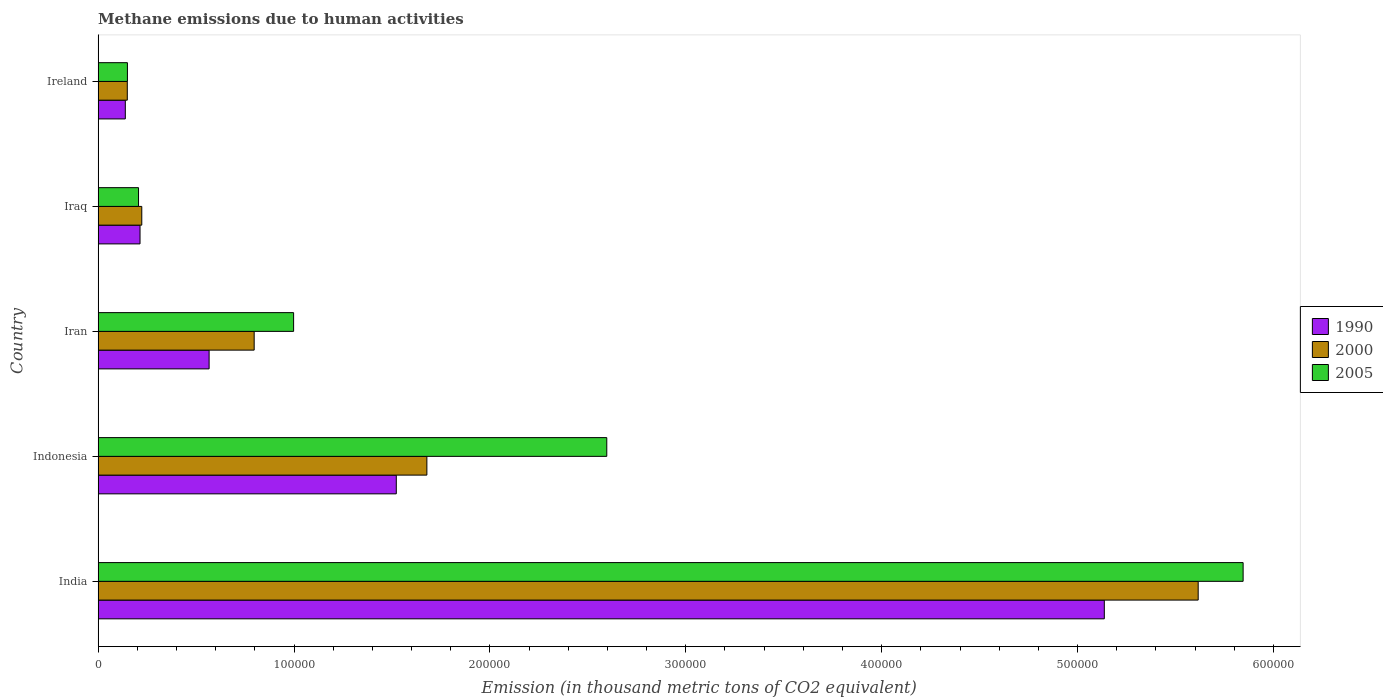How many different coloured bars are there?
Offer a very short reply. 3. How many bars are there on the 2nd tick from the top?
Provide a short and direct response. 3. What is the label of the 3rd group of bars from the top?
Your answer should be compact. Iran. In how many cases, is the number of bars for a given country not equal to the number of legend labels?
Your answer should be very brief. 0. What is the amount of methane emitted in 2005 in Ireland?
Ensure brevity in your answer.  1.50e+04. Across all countries, what is the maximum amount of methane emitted in 1990?
Your answer should be compact. 5.14e+05. Across all countries, what is the minimum amount of methane emitted in 2005?
Give a very brief answer. 1.50e+04. In which country was the amount of methane emitted in 1990 minimum?
Offer a very short reply. Ireland. What is the total amount of methane emitted in 2005 in the graph?
Offer a terse response. 9.80e+05. What is the difference between the amount of methane emitted in 2005 in Indonesia and that in Iraq?
Give a very brief answer. 2.39e+05. What is the difference between the amount of methane emitted in 2000 in Ireland and the amount of methane emitted in 1990 in Iran?
Make the answer very short. -4.18e+04. What is the average amount of methane emitted in 2000 per country?
Your response must be concise. 1.69e+05. What is the difference between the amount of methane emitted in 1990 and amount of methane emitted in 2005 in Ireland?
Ensure brevity in your answer.  -1076.2. What is the ratio of the amount of methane emitted in 2000 in India to that in Indonesia?
Provide a succinct answer. 3.35. Is the amount of methane emitted in 1990 in Indonesia less than that in Ireland?
Keep it short and to the point. No. What is the difference between the highest and the second highest amount of methane emitted in 2000?
Your answer should be very brief. 3.94e+05. What is the difference between the highest and the lowest amount of methane emitted in 2005?
Your answer should be compact. 5.70e+05. How many bars are there?
Give a very brief answer. 15. What is the difference between two consecutive major ticks on the X-axis?
Your answer should be compact. 1.00e+05. Are the values on the major ticks of X-axis written in scientific E-notation?
Give a very brief answer. No. Does the graph contain grids?
Your answer should be compact. No. Where does the legend appear in the graph?
Offer a terse response. Center right. How are the legend labels stacked?
Provide a short and direct response. Vertical. What is the title of the graph?
Give a very brief answer. Methane emissions due to human activities. Does "1987" appear as one of the legend labels in the graph?
Make the answer very short. No. What is the label or title of the X-axis?
Give a very brief answer. Emission (in thousand metric tons of CO2 equivalent). What is the label or title of the Y-axis?
Offer a terse response. Country. What is the Emission (in thousand metric tons of CO2 equivalent) of 1990 in India?
Make the answer very short. 5.14e+05. What is the Emission (in thousand metric tons of CO2 equivalent) in 2000 in India?
Make the answer very short. 5.62e+05. What is the Emission (in thousand metric tons of CO2 equivalent) in 2005 in India?
Your answer should be very brief. 5.84e+05. What is the Emission (in thousand metric tons of CO2 equivalent) of 1990 in Indonesia?
Your response must be concise. 1.52e+05. What is the Emission (in thousand metric tons of CO2 equivalent) in 2000 in Indonesia?
Your response must be concise. 1.68e+05. What is the Emission (in thousand metric tons of CO2 equivalent) in 2005 in Indonesia?
Offer a very short reply. 2.60e+05. What is the Emission (in thousand metric tons of CO2 equivalent) in 1990 in Iran?
Your response must be concise. 5.67e+04. What is the Emission (in thousand metric tons of CO2 equivalent) in 2000 in Iran?
Offer a very short reply. 7.97e+04. What is the Emission (in thousand metric tons of CO2 equivalent) of 2005 in Iran?
Provide a succinct answer. 9.98e+04. What is the Emission (in thousand metric tons of CO2 equivalent) of 1990 in Iraq?
Offer a terse response. 2.14e+04. What is the Emission (in thousand metric tons of CO2 equivalent) of 2000 in Iraq?
Your answer should be very brief. 2.23e+04. What is the Emission (in thousand metric tons of CO2 equivalent) of 2005 in Iraq?
Make the answer very short. 2.06e+04. What is the Emission (in thousand metric tons of CO2 equivalent) in 1990 in Ireland?
Provide a succinct answer. 1.39e+04. What is the Emission (in thousand metric tons of CO2 equivalent) of 2000 in Ireland?
Provide a short and direct response. 1.49e+04. What is the Emission (in thousand metric tons of CO2 equivalent) of 2005 in Ireland?
Provide a succinct answer. 1.50e+04. Across all countries, what is the maximum Emission (in thousand metric tons of CO2 equivalent) of 1990?
Keep it short and to the point. 5.14e+05. Across all countries, what is the maximum Emission (in thousand metric tons of CO2 equivalent) in 2000?
Ensure brevity in your answer.  5.62e+05. Across all countries, what is the maximum Emission (in thousand metric tons of CO2 equivalent) in 2005?
Offer a very short reply. 5.84e+05. Across all countries, what is the minimum Emission (in thousand metric tons of CO2 equivalent) in 1990?
Keep it short and to the point. 1.39e+04. Across all countries, what is the minimum Emission (in thousand metric tons of CO2 equivalent) in 2000?
Ensure brevity in your answer.  1.49e+04. Across all countries, what is the minimum Emission (in thousand metric tons of CO2 equivalent) in 2005?
Your answer should be very brief. 1.50e+04. What is the total Emission (in thousand metric tons of CO2 equivalent) in 1990 in the graph?
Your answer should be compact. 7.58e+05. What is the total Emission (in thousand metric tons of CO2 equivalent) in 2000 in the graph?
Provide a succinct answer. 8.46e+05. What is the total Emission (in thousand metric tons of CO2 equivalent) in 2005 in the graph?
Ensure brevity in your answer.  9.80e+05. What is the difference between the Emission (in thousand metric tons of CO2 equivalent) in 1990 in India and that in Indonesia?
Provide a succinct answer. 3.61e+05. What is the difference between the Emission (in thousand metric tons of CO2 equivalent) in 2000 in India and that in Indonesia?
Provide a short and direct response. 3.94e+05. What is the difference between the Emission (in thousand metric tons of CO2 equivalent) in 2005 in India and that in Indonesia?
Your response must be concise. 3.25e+05. What is the difference between the Emission (in thousand metric tons of CO2 equivalent) in 1990 in India and that in Iran?
Provide a short and direct response. 4.57e+05. What is the difference between the Emission (in thousand metric tons of CO2 equivalent) of 2000 in India and that in Iran?
Your answer should be very brief. 4.82e+05. What is the difference between the Emission (in thousand metric tons of CO2 equivalent) of 2005 in India and that in Iran?
Your response must be concise. 4.85e+05. What is the difference between the Emission (in thousand metric tons of CO2 equivalent) in 1990 in India and that in Iraq?
Offer a terse response. 4.92e+05. What is the difference between the Emission (in thousand metric tons of CO2 equivalent) in 2000 in India and that in Iraq?
Make the answer very short. 5.39e+05. What is the difference between the Emission (in thousand metric tons of CO2 equivalent) in 2005 in India and that in Iraq?
Provide a short and direct response. 5.64e+05. What is the difference between the Emission (in thousand metric tons of CO2 equivalent) in 1990 in India and that in Ireland?
Ensure brevity in your answer.  5.00e+05. What is the difference between the Emission (in thousand metric tons of CO2 equivalent) in 2000 in India and that in Ireland?
Give a very brief answer. 5.47e+05. What is the difference between the Emission (in thousand metric tons of CO2 equivalent) in 2005 in India and that in Ireland?
Keep it short and to the point. 5.70e+05. What is the difference between the Emission (in thousand metric tons of CO2 equivalent) in 1990 in Indonesia and that in Iran?
Offer a terse response. 9.55e+04. What is the difference between the Emission (in thousand metric tons of CO2 equivalent) in 2000 in Indonesia and that in Iran?
Keep it short and to the point. 8.82e+04. What is the difference between the Emission (in thousand metric tons of CO2 equivalent) of 2005 in Indonesia and that in Iran?
Offer a terse response. 1.60e+05. What is the difference between the Emission (in thousand metric tons of CO2 equivalent) in 1990 in Indonesia and that in Iraq?
Offer a very short reply. 1.31e+05. What is the difference between the Emission (in thousand metric tons of CO2 equivalent) of 2000 in Indonesia and that in Iraq?
Offer a very short reply. 1.46e+05. What is the difference between the Emission (in thousand metric tons of CO2 equivalent) in 2005 in Indonesia and that in Iraq?
Keep it short and to the point. 2.39e+05. What is the difference between the Emission (in thousand metric tons of CO2 equivalent) of 1990 in Indonesia and that in Ireland?
Your response must be concise. 1.38e+05. What is the difference between the Emission (in thousand metric tons of CO2 equivalent) in 2000 in Indonesia and that in Ireland?
Your response must be concise. 1.53e+05. What is the difference between the Emission (in thousand metric tons of CO2 equivalent) of 2005 in Indonesia and that in Ireland?
Provide a short and direct response. 2.45e+05. What is the difference between the Emission (in thousand metric tons of CO2 equivalent) in 1990 in Iran and that in Iraq?
Make the answer very short. 3.53e+04. What is the difference between the Emission (in thousand metric tons of CO2 equivalent) of 2000 in Iran and that in Iraq?
Your answer should be very brief. 5.74e+04. What is the difference between the Emission (in thousand metric tons of CO2 equivalent) of 2005 in Iran and that in Iraq?
Provide a succinct answer. 7.92e+04. What is the difference between the Emission (in thousand metric tons of CO2 equivalent) in 1990 in Iran and that in Ireland?
Make the answer very short. 4.28e+04. What is the difference between the Emission (in thousand metric tons of CO2 equivalent) in 2000 in Iran and that in Ireland?
Give a very brief answer. 6.48e+04. What is the difference between the Emission (in thousand metric tons of CO2 equivalent) in 2005 in Iran and that in Ireland?
Ensure brevity in your answer.  8.48e+04. What is the difference between the Emission (in thousand metric tons of CO2 equivalent) in 1990 in Iraq and that in Ireland?
Your answer should be compact. 7511.4. What is the difference between the Emission (in thousand metric tons of CO2 equivalent) in 2000 in Iraq and that in Ireland?
Offer a terse response. 7392. What is the difference between the Emission (in thousand metric tons of CO2 equivalent) in 2005 in Iraq and that in Ireland?
Keep it short and to the point. 5668. What is the difference between the Emission (in thousand metric tons of CO2 equivalent) in 1990 in India and the Emission (in thousand metric tons of CO2 equivalent) in 2000 in Indonesia?
Your response must be concise. 3.46e+05. What is the difference between the Emission (in thousand metric tons of CO2 equivalent) of 1990 in India and the Emission (in thousand metric tons of CO2 equivalent) of 2005 in Indonesia?
Your answer should be compact. 2.54e+05. What is the difference between the Emission (in thousand metric tons of CO2 equivalent) in 2000 in India and the Emission (in thousand metric tons of CO2 equivalent) in 2005 in Indonesia?
Your answer should be very brief. 3.02e+05. What is the difference between the Emission (in thousand metric tons of CO2 equivalent) of 1990 in India and the Emission (in thousand metric tons of CO2 equivalent) of 2000 in Iran?
Provide a short and direct response. 4.34e+05. What is the difference between the Emission (in thousand metric tons of CO2 equivalent) in 1990 in India and the Emission (in thousand metric tons of CO2 equivalent) in 2005 in Iran?
Provide a short and direct response. 4.14e+05. What is the difference between the Emission (in thousand metric tons of CO2 equivalent) in 2000 in India and the Emission (in thousand metric tons of CO2 equivalent) in 2005 in Iran?
Your answer should be very brief. 4.62e+05. What is the difference between the Emission (in thousand metric tons of CO2 equivalent) of 1990 in India and the Emission (in thousand metric tons of CO2 equivalent) of 2000 in Iraq?
Provide a succinct answer. 4.91e+05. What is the difference between the Emission (in thousand metric tons of CO2 equivalent) of 1990 in India and the Emission (in thousand metric tons of CO2 equivalent) of 2005 in Iraq?
Make the answer very short. 4.93e+05. What is the difference between the Emission (in thousand metric tons of CO2 equivalent) in 2000 in India and the Emission (in thousand metric tons of CO2 equivalent) in 2005 in Iraq?
Offer a very short reply. 5.41e+05. What is the difference between the Emission (in thousand metric tons of CO2 equivalent) in 1990 in India and the Emission (in thousand metric tons of CO2 equivalent) in 2000 in Ireland?
Offer a terse response. 4.99e+05. What is the difference between the Emission (in thousand metric tons of CO2 equivalent) of 1990 in India and the Emission (in thousand metric tons of CO2 equivalent) of 2005 in Ireland?
Your answer should be very brief. 4.99e+05. What is the difference between the Emission (in thousand metric tons of CO2 equivalent) of 2000 in India and the Emission (in thousand metric tons of CO2 equivalent) of 2005 in Ireland?
Provide a short and direct response. 5.47e+05. What is the difference between the Emission (in thousand metric tons of CO2 equivalent) of 1990 in Indonesia and the Emission (in thousand metric tons of CO2 equivalent) of 2000 in Iran?
Keep it short and to the point. 7.25e+04. What is the difference between the Emission (in thousand metric tons of CO2 equivalent) of 1990 in Indonesia and the Emission (in thousand metric tons of CO2 equivalent) of 2005 in Iran?
Keep it short and to the point. 5.24e+04. What is the difference between the Emission (in thousand metric tons of CO2 equivalent) of 2000 in Indonesia and the Emission (in thousand metric tons of CO2 equivalent) of 2005 in Iran?
Make the answer very short. 6.80e+04. What is the difference between the Emission (in thousand metric tons of CO2 equivalent) of 1990 in Indonesia and the Emission (in thousand metric tons of CO2 equivalent) of 2000 in Iraq?
Provide a succinct answer. 1.30e+05. What is the difference between the Emission (in thousand metric tons of CO2 equivalent) in 1990 in Indonesia and the Emission (in thousand metric tons of CO2 equivalent) in 2005 in Iraq?
Keep it short and to the point. 1.32e+05. What is the difference between the Emission (in thousand metric tons of CO2 equivalent) of 2000 in Indonesia and the Emission (in thousand metric tons of CO2 equivalent) of 2005 in Iraq?
Your response must be concise. 1.47e+05. What is the difference between the Emission (in thousand metric tons of CO2 equivalent) in 1990 in Indonesia and the Emission (in thousand metric tons of CO2 equivalent) in 2000 in Ireland?
Your answer should be very brief. 1.37e+05. What is the difference between the Emission (in thousand metric tons of CO2 equivalent) in 1990 in Indonesia and the Emission (in thousand metric tons of CO2 equivalent) in 2005 in Ireland?
Ensure brevity in your answer.  1.37e+05. What is the difference between the Emission (in thousand metric tons of CO2 equivalent) in 2000 in Indonesia and the Emission (in thousand metric tons of CO2 equivalent) in 2005 in Ireland?
Give a very brief answer. 1.53e+05. What is the difference between the Emission (in thousand metric tons of CO2 equivalent) of 1990 in Iran and the Emission (in thousand metric tons of CO2 equivalent) of 2000 in Iraq?
Provide a short and direct response. 3.44e+04. What is the difference between the Emission (in thousand metric tons of CO2 equivalent) in 1990 in Iran and the Emission (in thousand metric tons of CO2 equivalent) in 2005 in Iraq?
Make the answer very short. 3.60e+04. What is the difference between the Emission (in thousand metric tons of CO2 equivalent) in 2000 in Iran and the Emission (in thousand metric tons of CO2 equivalent) in 2005 in Iraq?
Make the answer very short. 5.90e+04. What is the difference between the Emission (in thousand metric tons of CO2 equivalent) of 1990 in Iran and the Emission (in thousand metric tons of CO2 equivalent) of 2000 in Ireland?
Ensure brevity in your answer.  4.18e+04. What is the difference between the Emission (in thousand metric tons of CO2 equivalent) of 1990 in Iran and the Emission (in thousand metric tons of CO2 equivalent) of 2005 in Ireland?
Keep it short and to the point. 4.17e+04. What is the difference between the Emission (in thousand metric tons of CO2 equivalent) in 2000 in Iran and the Emission (in thousand metric tons of CO2 equivalent) in 2005 in Ireland?
Ensure brevity in your answer.  6.47e+04. What is the difference between the Emission (in thousand metric tons of CO2 equivalent) of 1990 in Iraq and the Emission (in thousand metric tons of CO2 equivalent) of 2000 in Ireland?
Ensure brevity in your answer.  6498.3. What is the difference between the Emission (in thousand metric tons of CO2 equivalent) in 1990 in Iraq and the Emission (in thousand metric tons of CO2 equivalent) in 2005 in Ireland?
Offer a terse response. 6435.2. What is the difference between the Emission (in thousand metric tons of CO2 equivalent) in 2000 in Iraq and the Emission (in thousand metric tons of CO2 equivalent) in 2005 in Ireland?
Provide a short and direct response. 7328.9. What is the average Emission (in thousand metric tons of CO2 equivalent) of 1990 per country?
Make the answer very short. 1.52e+05. What is the average Emission (in thousand metric tons of CO2 equivalent) in 2000 per country?
Your answer should be compact. 1.69e+05. What is the average Emission (in thousand metric tons of CO2 equivalent) of 2005 per country?
Keep it short and to the point. 1.96e+05. What is the difference between the Emission (in thousand metric tons of CO2 equivalent) of 1990 and Emission (in thousand metric tons of CO2 equivalent) of 2000 in India?
Ensure brevity in your answer.  -4.79e+04. What is the difference between the Emission (in thousand metric tons of CO2 equivalent) in 1990 and Emission (in thousand metric tons of CO2 equivalent) in 2005 in India?
Ensure brevity in your answer.  -7.09e+04. What is the difference between the Emission (in thousand metric tons of CO2 equivalent) of 2000 and Emission (in thousand metric tons of CO2 equivalent) of 2005 in India?
Offer a very short reply. -2.29e+04. What is the difference between the Emission (in thousand metric tons of CO2 equivalent) in 1990 and Emission (in thousand metric tons of CO2 equivalent) in 2000 in Indonesia?
Make the answer very short. -1.56e+04. What is the difference between the Emission (in thousand metric tons of CO2 equivalent) of 1990 and Emission (in thousand metric tons of CO2 equivalent) of 2005 in Indonesia?
Your answer should be very brief. -1.07e+05. What is the difference between the Emission (in thousand metric tons of CO2 equivalent) in 2000 and Emission (in thousand metric tons of CO2 equivalent) in 2005 in Indonesia?
Ensure brevity in your answer.  -9.18e+04. What is the difference between the Emission (in thousand metric tons of CO2 equivalent) of 1990 and Emission (in thousand metric tons of CO2 equivalent) of 2000 in Iran?
Provide a short and direct response. -2.30e+04. What is the difference between the Emission (in thousand metric tons of CO2 equivalent) in 1990 and Emission (in thousand metric tons of CO2 equivalent) in 2005 in Iran?
Your response must be concise. -4.31e+04. What is the difference between the Emission (in thousand metric tons of CO2 equivalent) of 2000 and Emission (in thousand metric tons of CO2 equivalent) of 2005 in Iran?
Offer a very short reply. -2.01e+04. What is the difference between the Emission (in thousand metric tons of CO2 equivalent) in 1990 and Emission (in thousand metric tons of CO2 equivalent) in 2000 in Iraq?
Make the answer very short. -893.7. What is the difference between the Emission (in thousand metric tons of CO2 equivalent) in 1990 and Emission (in thousand metric tons of CO2 equivalent) in 2005 in Iraq?
Provide a short and direct response. 767.2. What is the difference between the Emission (in thousand metric tons of CO2 equivalent) in 2000 and Emission (in thousand metric tons of CO2 equivalent) in 2005 in Iraq?
Ensure brevity in your answer.  1660.9. What is the difference between the Emission (in thousand metric tons of CO2 equivalent) of 1990 and Emission (in thousand metric tons of CO2 equivalent) of 2000 in Ireland?
Ensure brevity in your answer.  -1013.1. What is the difference between the Emission (in thousand metric tons of CO2 equivalent) in 1990 and Emission (in thousand metric tons of CO2 equivalent) in 2005 in Ireland?
Give a very brief answer. -1076.2. What is the difference between the Emission (in thousand metric tons of CO2 equivalent) in 2000 and Emission (in thousand metric tons of CO2 equivalent) in 2005 in Ireland?
Offer a very short reply. -63.1. What is the ratio of the Emission (in thousand metric tons of CO2 equivalent) of 1990 in India to that in Indonesia?
Your answer should be very brief. 3.37. What is the ratio of the Emission (in thousand metric tons of CO2 equivalent) of 2000 in India to that in Indonesia?
Make the answer very short. 3.35. What is the ratio of the Emission (in thousand metric tons of CO2 equivalent) of 2005 in India to that in Indonesia?
Give a very brief answer. 2.25. What is the ratio of the Emission (in thousand metric tons of CO2 equivalent) of 1990 in India to that in Iran?
Give a very brief answer. 9.06. What is the ratio of the Emission (in thousand metric tons of CO2 equivalent) of 2000 in India to that in Iran?
Offer a very short reply. 7.05. What is the ratio of the Emission (in thousand metric tons of CO2 equivalent) in 2005 in India to that in Iran?
Your answer should be very brief. 5.86. What is the ratio of the Emission (in thousand metric tons of CO2 equivalent) of 1990 in India to that in Iraq?
Your response must be concise. 24.01. What is the ratio of the Emission (in thousand metric tons of CO2 equivalent) in 2000 in India to that in Iraq?
Make the answer very short. 25.19. What is the ratio of the Emission (in thousand metric tons of CO2 equivalent) in 2005 in India to that in Iraq?
Offer a very short reply. 28.33. What is the ratio of the Emission (in thousand metric tons of CO2 equivalent) of 1990 in India to that in Ireland?
Ensure brevity in your answer.  37. What is the ratio of the Emission (in thousand metric tons of CO2 equivalent) of 2000 in India to that in Ireland?
Provide a succinct answer. 37.7. What is the ratio of the Emission (in thousand metric tons of CO2 equivalent) in 2005 in India to that in Ireland?
Keep it short and to the point. 39.07. What is the ratio of the Emission (in thousand metric tons of CO2 equivalent) in 1990 in Indonesia to that in Iran?
Your answer should be compact. 2.69. What is the ratio of the Emission (in thousand metric tons of CO2 equivalent) in 2000 in Indonesia to that in Iran?
Ensure brevity in your answer.  2.11. What is the ratio of the Emission (in thousand metric tons of CO2 equivalent) of 2005 in Indonesia to that in Iran?
Offer a very short reply. 2.6. What is the ratio of the Emission (in thousand metric tons of CO2 equivalent) in 1990 in Indonesia to that in Iraq?
Give a very brief answer. 7.11. What is the ratio of the Emission (in thousand metric tons of CO2 equivalent) of 2000 in Indonesia to that in Iraq?
Provide a succinct answer. 7.53. What is the ratio of the Emission (in thousand metric tons of CO2 equivalent) of 2005 in Indonesia to that in Iraq?
Provide a succinct answer. 12.59. What is the ratio of the Emission (in thousand metric tons of CO2 equivalent) in 1990 in Indonesia to that in Ireland?
Offer a very short reply. 10.96. What is the ratio of the Emission (in thousand metric tons of CO2 equivalent) of 2000 in Indonesia to that in Ireland?
Give a very brief answer. 11.27. What is the ratio of the Emission (in thousand metric tons of CO2 equivalent) in 2005 in Indonesia to that in Ireland?
Your response must be concise. 17.36. What is the ratio of the Emission (in thousand metric tons of CO2 equivalent) in 1990 in Iran to that in Iraq?
Offer a very short reply. 2.65. What is the ratio of the Emission (in thousand metric tons of CO2 equivalent) in 2000 in Iran to that in Iraq?
Your answer should be very brief. 3.57. What is the ratio of the Emission (in thousand metric tons of CO2 equivalent) of 2005 in Iran to that in Iraq?
Ensure brevity in your answer.  4.84. What is the ratio of the Emission (in thousand metric tons of CO2 equivalent) of 1990 in Iran to that in Ireland?
Your response must be concise. 4.08. What is the ratio of the Emission (in thousand metric tons of CO2 equivalent) of 2000 in Iran to that in Ireland?
Make the answer very short. 5.35. What is the ratio of the Emission (in thousand metric tons of CO2 equivalent) in 2005 in Iran to that in Ireland?
Give a very brief answer. 6.67. What is the ratio of the Emission (in thousand metric tons of CO2 equivalent) of 1990 in Iraq to that in Ireland?
Offer a terse response. 1.54. What is the ratio of the Emission (in thousand metric tons of CO2 equivalent) of 2000 in Iraq to that in Ireland?
Offer a terse response. 1.5. What is the ratio of the Emission (in thousand metric tons of CO2 equivalent) in 2005 in Iraq to that in Ireland?
Your answer should be very brief. 1.38. What is the difference between the highest and the second highest Emission (in thousand metric tons of CO2 equivalent) of 1990?
Give a very brief answer. 3.61e+05. What is the difference between the highest and the second highest Emission (in thousand metric tons of CO2 equivalent) of 2000?
Your answer should be very brief. 3.94e+05. What is the difference between the highest and the second highest Emission (in thousand metric tons of CO2 equivalent) of 2005?
Offer a very short reply. 3.25e+05. What is the difference between the highest and the lowest Emission (in thousand metric tons of CO2 equivalent) in 1990?
Your answer should be compact. 5.00e+05. What is the difference between the highest and the lowest Emission (in thousand metric tons of CO2 equivalent) of 2000?
Ensure brevity in your answer.  5.47e+05. What is the difference between the highest and the lowest Emission (in thousand metric tons of CO2 equivalent) of 2005?
Offer a terse response. 5.70e+05. 